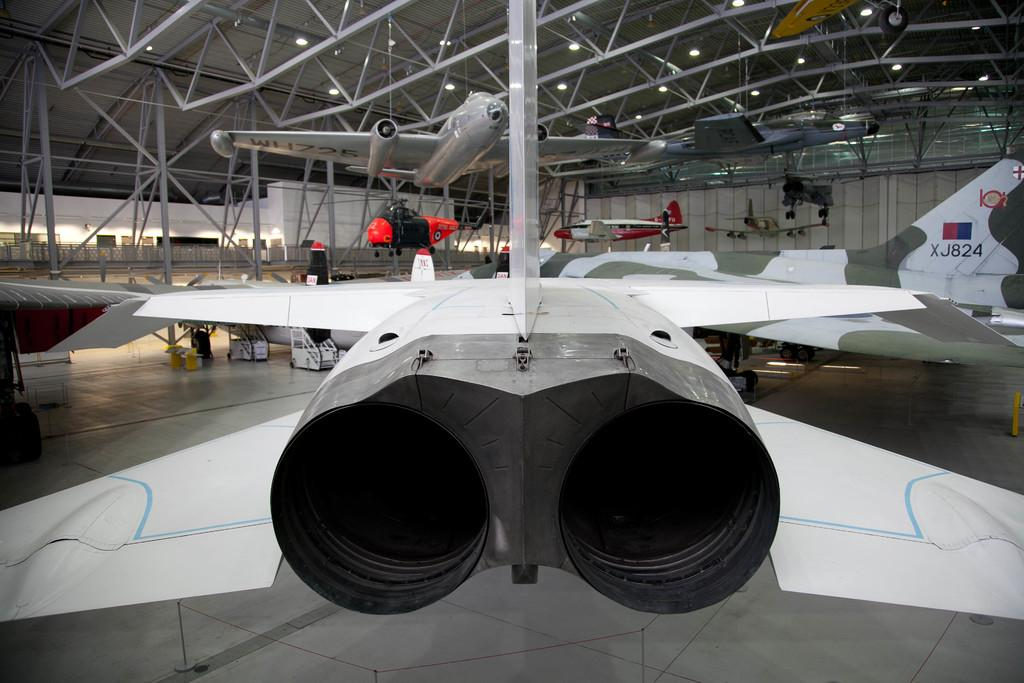<image>
Describe the image concisely. airplanes on display in a hangar include one with number XJ824 on the tail 